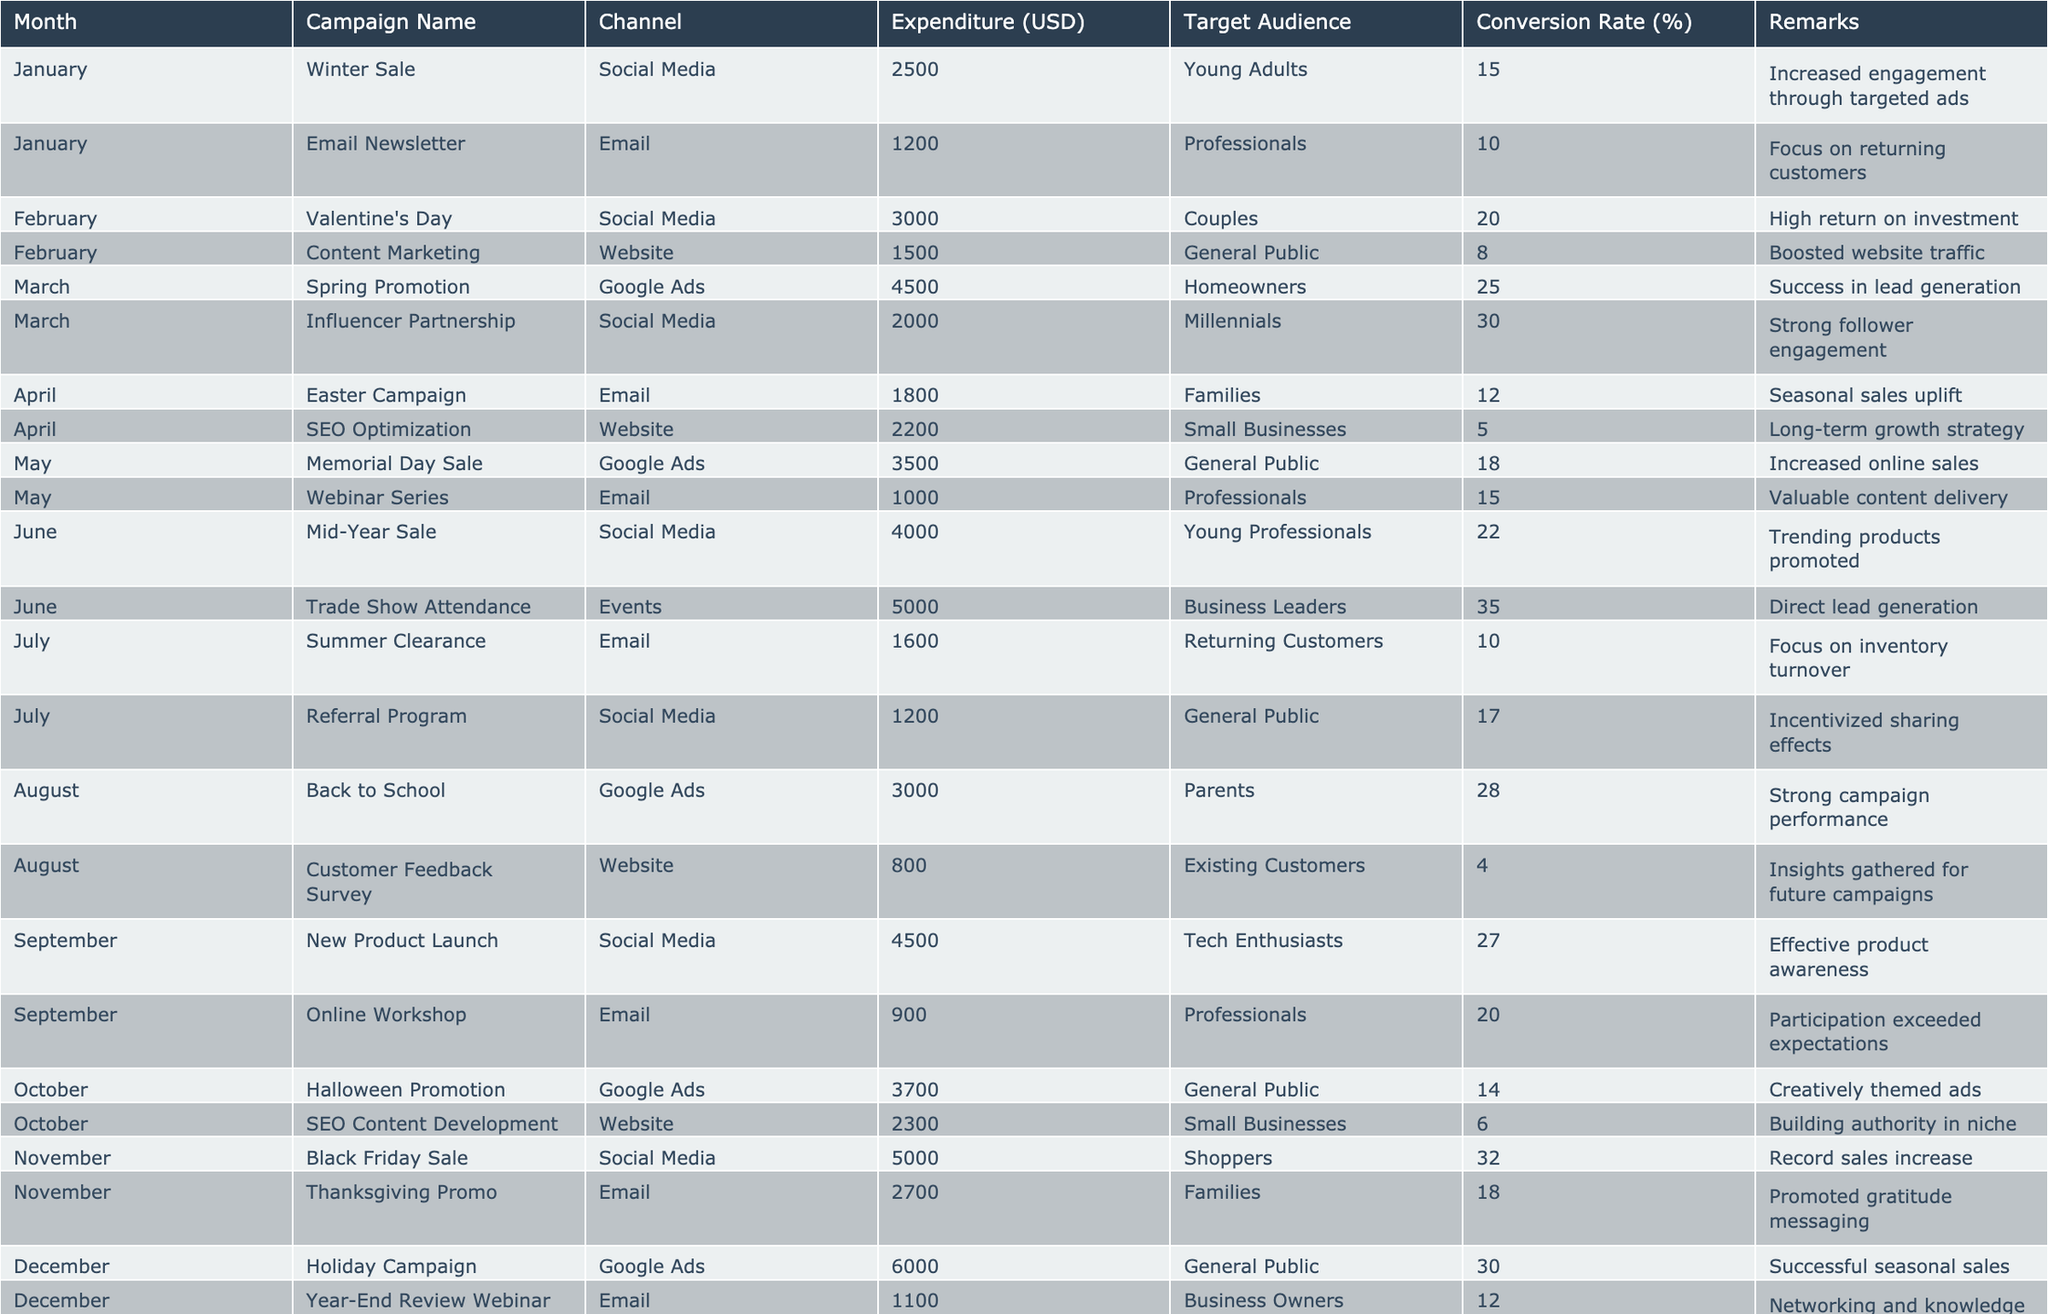What was the highest expenditure recorded in June? In June, the expenditures recorded were 4000 for Mid-Year Sale and 5000 for Trade Show Attendance. Indeed, 5000 is higher; hence it is the highest amount.
Answer: 5000 What is the average conversion rate for campaigns in August? In August, the conversion rates are 28 for Back to School and 4 for Customer Feedback Survey. To get the average, add these two values (28 + 4 = 32) and divide by the number of campaigns in that month (32 / 2 = 16).
Answer: 16 Did the Valentine’s Day campaign have a higher conversion rate than the Easter Campaign? The conversion rate for Valentine's Day is 20%, while for Easter Campaign it is 12%. Since 20% is higher than 12%, the statement is true.
Answer: Yes What was the total expenditure for Social Media campaigns over the year? The expenditures for Social Media campaigns are: 2500 (Winter Sale) + 3000 (Valentine's Day) + 2000 (Influencer Partnership) + 4000 (Mid-Year Sale) + 1200 (Referral Program) + 4500 (New Product Launch) + 5000 (Black Friday Sale) = 22000.
Answer: 22000 Which month had the lowest expenditure for campaigns, and what was the amount? The expenditure for campaigns in July is 1600 for Summer Clearance, which is the lowest compared to all other months.
Answer: July, 1600 What is the ratio of conversion rates for the Trade Show Attendance campaign compared to the Webinar Series campaign? The conversion rate for Trade Show Attendance is 35%, while for Webinar Series it is 15%. The ratio is therefore 35:15, which simplifies to 7:3.
Answer: 7:3 What is the total expenditure for Email campaigns in the second quarter? In the second quarter (April, May, June), the expenditures for Email campaigns are 1800 (Easter Campaign), 1000 (Webinar Series), and 1100 (Year-End Review Webinar). Adding these gives 1800 + 1000 + 1100 = 3900.
Answer: 3900 Was the Holiday Campaign the campaign with the highest conversion rate in December? The Holiday Campaign had a conversion rate of 30%, while the Year-End Review Webinar had a conversion rate of 12%. Since 30% is greater than 12%, it is indeed the highest in December.
Answer: Yes 